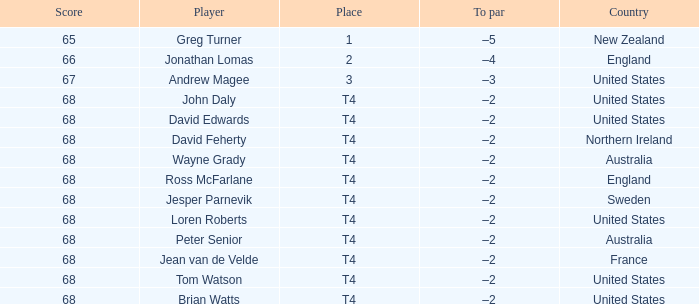Name the Score united states of tom watson in united state? 68.0. 